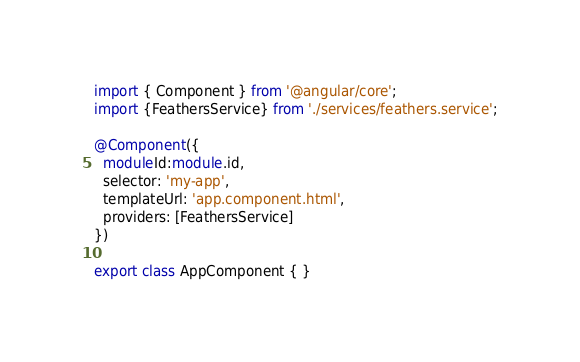Convert code to text. <code><loc_0><loc_0><loc_500><loc_500><_TypeScript_>import { Component } from '@angular/core';
import {FeathersService} from './services/feathers.service';

@Component({
  moduleId:module.id,
  selector: 'my-app',
  templateUrl: 'app.component.html',
  providers: [FeathersService]
})

export class AppComponent { }
</code> 